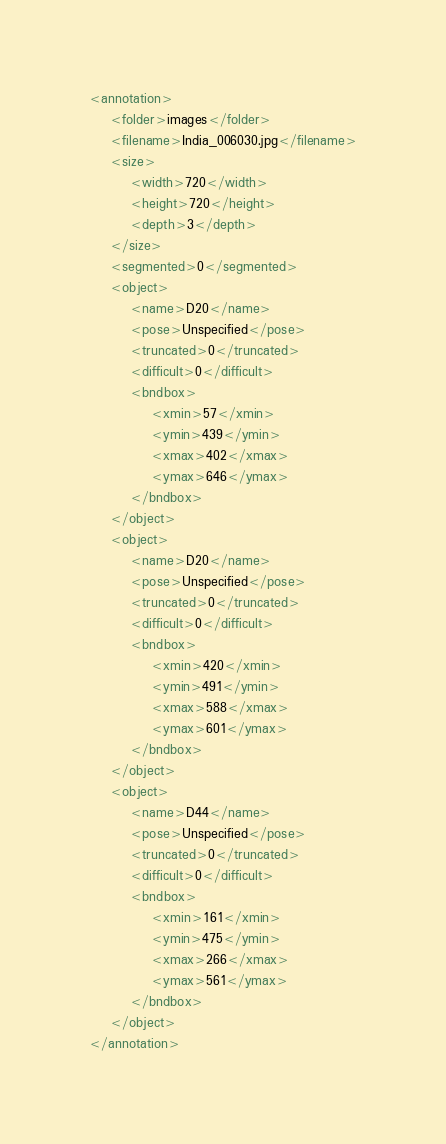Convert code to text. <code><loc_0><loc_0><loc_500><loc_500><_XML_><annotation>
	<folder>images</folder>
	<filename>India_006030.jpg</filename>
	<size>
		<width>720</width>
		<height>720</height>
		<depth>3</depth>
	</size>
	<segmented>0</segmented>
	<object>
		<name>D20</name>
		<pose>Unspecified</pose>
		<truncated>0</truncated>
		<difficult>0</difficult>
		<bndbox>
			<xmin>57</xmin>
			<ymin>439</ymin>
			<xmax>402</xmax>
			<ymax>646</ymax>
		</bndbox>
	</object>
	<object>
		<name>D20</name>
		<pose>Unspecified</pose>
		<truncated>0</truncated>
		<difficult>0</difficult>
		<bndbox>
			<xmin>420</xmin>
			<ymin>491</ymin>
			<xmax>588</xmax>
			<ymax>601</ymax>
		</bndbox>
	</object>
	<object>
		<name>D44</name>
		<pose>Unspecified</pose>
		<truncated>0</truncated>
		<difficult>0</difficult>
		<bndbox>
			<xmin>161</xmin>
			<ymin>475</ymin>
			<xmax>266</xmax>
			<ymax>561</ymax>
		</bndbox>
	</object>
</annotation></code> 